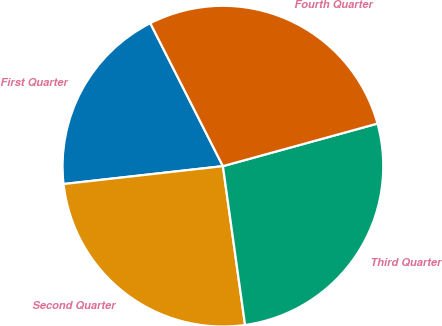Convert chart. <chart><loc_0><loc_0><loc_500><loc_500><pie_chart><fcel>First Quarter<fcel>Second Quarter<fcel>Third Quarter<fcel>Fourth Quarter<nl><fcel>19.3%<fcel>25.43%<fcel>27.07%<fcel>28.2%<nl></chart> 